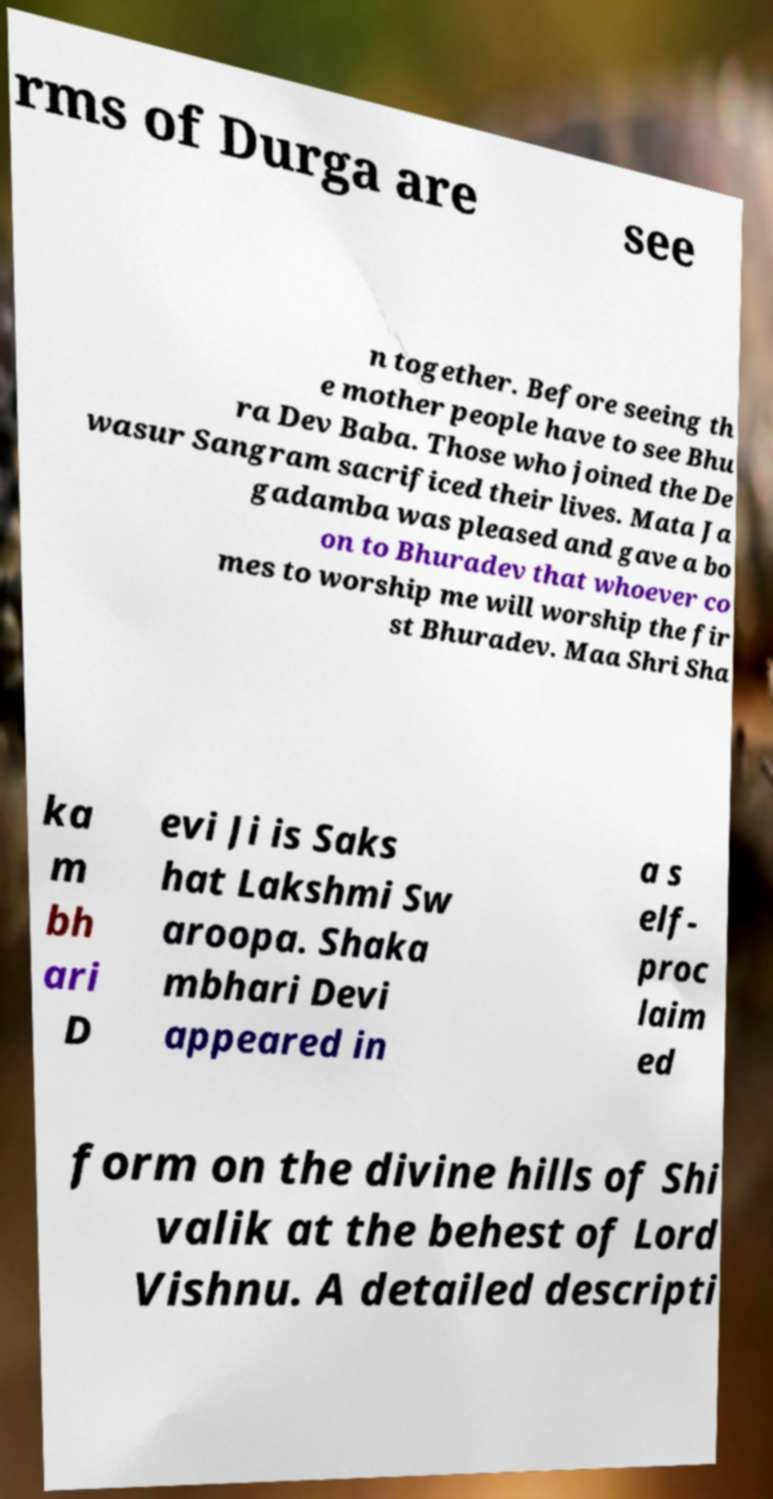For documentation purposes, I need the text within this image transcribed. Could you provide that? rms of Durga are see n together. Before seeing th e mother people have to see Bhu ra Dev Baba. Those who joined the De wasur Sangram sacrificed their lives. Mata Ja gadamba was pleased and gave a bo on to Bhuradev that whoever co mes to worship me will worship the fir st Bhuradev. Maa Shri Sha ka m bh ari D evi Ji is Saks hat Lakshmi Sw aroopa. Shaka mbhari Devi appeared in a s elf- proc laim ed form on the divine hills of Shi valik at the behest of Lord Vishnu. A detailed descripti 